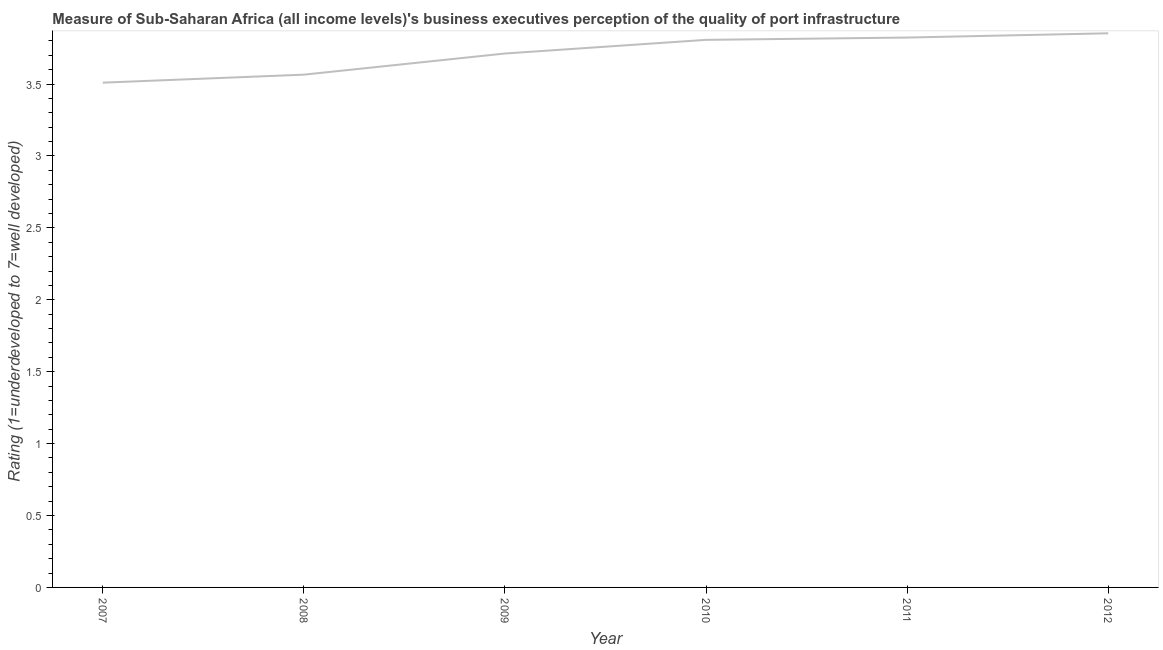What is the rating measuring quality of port infrastructure in 2011?
Provide a succinct answer. 3.82. Across all years, what is the maximum rating measuring quality of port infrastructure?
Keep it short and to the point. 3.85. Across all years, what is the minimum rating measuring quality of port infrastructure?
Keep it short and to the point. 3.51. What is the sum of the rating measuring quality of port infrastructure?
Keep it short and to the point. 22.27. What is the difference between the rating measuring quality of port infrastructure in 2009 and 2012?
Offer a very short reply. -0.14. What is the average rating measuring quality of port infrastructure per year?
Offer a very short reply. 3.71. What is the median rating measuring quality of port infrastructure?
Give a very brief answer. 3.76. What is the ratio of the rating measuring quality of port infrastructure in 2008 to that in 2010?
Your answer should be compact. 0.94. Is the rating measuring quality of port infrastructure in 2007 less than that in 2010?
Your answer should be compact. Yes. Is the difference between the rating measuring quality of port infrastructure in 2011 and 2012 greater than the difference between any two years?
Provide a succinct answer. No. What is the difference between the highest and the second highest rating measuring quality of port infrastructure?
Keep it short and to the point. 0.03. Is the sum of the rating measuring quality of port infrastructure in 2008 and 2011 greater than the maximum rating measuring quality of port infrastructure across all years?
Offer a terse response. Yes. What is the difference between the highest and the lowest rating measuring quality of port infrastructure?
Offer a terse response. 0.34. In how many years, is the rating measuring quality of port infrastructure greater than the average rating measuring quality of port infrastructure taken over all years?
Provide a short and direct response. 4. How many lines are there?
Make the answer very short. 1. What is the difference between two consecutive major ticks on the Y-axis?
Provide a succinct answer. 0.5. Are the values on the major ticks of Y-axis written in scientific E-notation?
Your answer should be very brief. No. What is the title of the graph?
Give a very brief answer. Measure of Sub-Saharan Africa (all income levels)'s business executives perception of the quality of port infrastructure. What is the label or title of the Y-axis?
Provide a short and direct response. Rating (1=underdeveloped to 7=well developed) . What is the Rating (1=underdeveloped to 7=well developed)  in 2007?
Ensure brevity in your answer.  3.51. What is the Rating (1=underdeveloped to 7=well developed)  in 2008?
Ensure brevity in your answer.  3.57. What is the Rating (1=underdeveloped to 7=well developed)  of 2009?
Provide a succinct answer. 3.71. What is the Rating (1=underdeveloped to 7=well developed)  in 2010?
Offer a very short reply. 3.81. What is the Rating (1=underdeveloped to 7=well developed)  of 2011?
Provide a short and direct response. 3.82. What is the Rating (1=underdeveloped to 7=well developed)  in 2012?
Your answer should be very brief. 3.85. What is the difference between the Rating (1=underdeveloped to 7=well developed)  in 2007 and 2008?
Keep it short and to the point. -0.06. What is the difference between the Rating (1=underdeveloped to 7=well developed)  in 2007 and 2009?
Your answer should be compact. -0.2. What is the difference between the Rating (1=underdeveloped to 7=well developed)  in 2007 and 2010?
Your answer should be very brief. -0.3. What is the difference between the Rating (1=underdeveloped to 7=well developed)  in 2007 and 2011?
Offer a terse response. -0.31. What is the difference between the Rating (1=underdeveloped to 7=well developed)  in 2007 and 2012?
Give a very brief answer. -0.34. What is the difference between the Rating (1=underdeveloped to 7=well developed)  in 2008 and 2009?
Ensure brevity in your answer.  -0.15. What is the difference between the Rating (1=underdeveloped to 7=well developed)  in 2008 and 2010?
Offer a very short reply. -0.24. What is the difference between the Rating (1=underdeveloped to 7=well developed)  in 2008 and 2011?
Your response must be concise. -0.26. What is the difference between the Rating (1=underdeveloped to 7=well developed)  in 2008 and 2012?
Your answer should be very brief. -0.29. What is the difference between the Rating (1=underdeveloped to 7=well developed)  in 2009 and 2010?
Offer a very short reply. -0.09. What is the difference between the Rating (1=underdeveloped to 7=well developed)  in 2009 and 2011?
Your answer should be very brief. -0.11. What is the difference between the Rating (1=underdeveloped to 7=well developed)  in 2009 and 2012?
Make the answer very short. -0.14. What is the difference between the Rating (1=underdeveloped to 7=well developed)  in 2010 and 2011?
Make the answer very short. -0.02. What is the difference between the Rating (1=underdeveloped to 7=well developed)  in 2010 and 2012?
Your answer should be very brief. -0.05. What is the difference between the Rating (1=underdeveloped to 7=well developed)  in 2011 and 2012?
Your response must be concise. -0.03. What is the ratio of the Rating (1=underdeveloped to 7=well developed)  in 2007 to that in 2009?
Your response must be concise. 0.94. What is the ratio of the Rating (1=underdeveloped to 7=well developed)  in 2007 to that in 2010?
Your answer should be compact. 0.92. What is the ratio of the Rating (1=underdeveloped to 7=well developed)  in 2007 to that in 2011?
Provide a short and direct response. 0.92. What is the ratio of the Rating (1=underdeveloped to 7=well developed)  in 2007 to that in 2012?
Offer a very short reply. 0.91. What is the ratio of the Rating (1=underdeveloped to 7=well developed)  in 2008 to that in 2010?
Keep it short and to the point. 0.94. What is the ratio of the Rating (1=underdeveloped to 7=well developed)  in 2008 to that in 2011?
Give a very brief answer. 0.93. What is the ratio of the Rating (1=underdeveloped to 7=well developed)  in 2008 to that in 2012?
Your answer should be very brief. 0.93. What is the ratio of the Rating (1=underdeveloped to 7=well developed)  in 2009 to that in 2010?
Give a very brief answer. 0.97. What is the ratio of the Rating (1=underdeveloped to 7=well developed)  in 2010 to that in 2012?
Your answer should be compact. 0.99. 